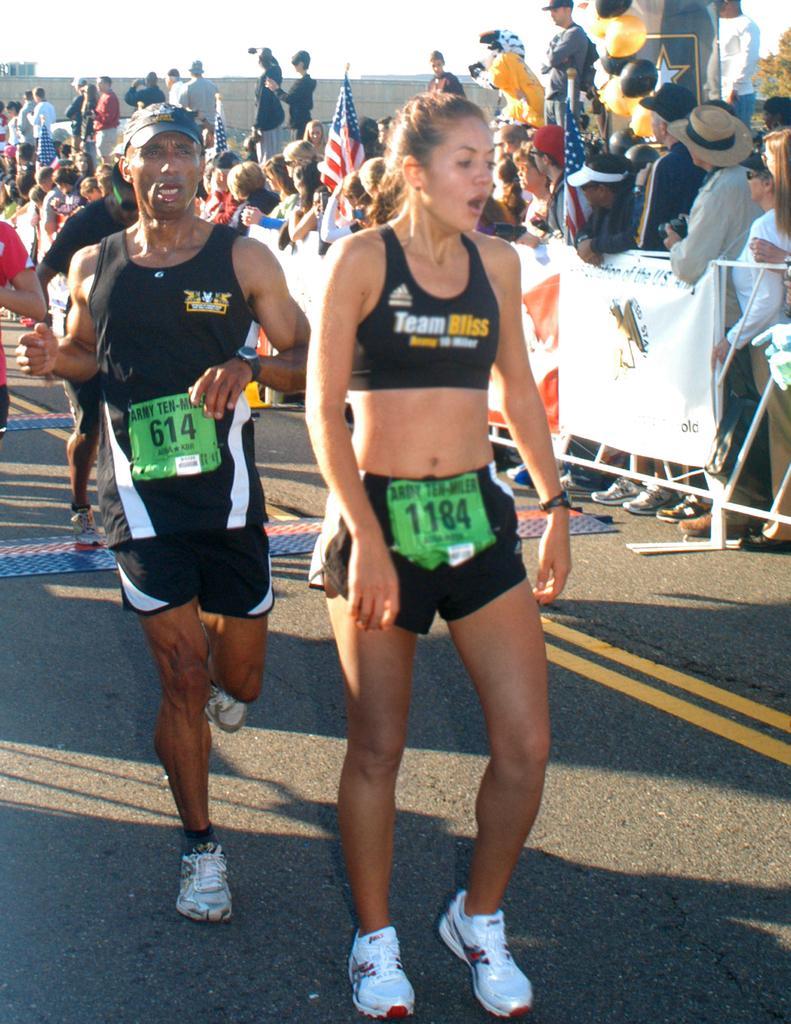Can you describe this image briefly? This picture shows few people standing and few people running and we see a metal fence and few of them wore caps on their heads and we see flags and a building and we see banners on the metal fence and a cloudy sky and we see few balloons. 